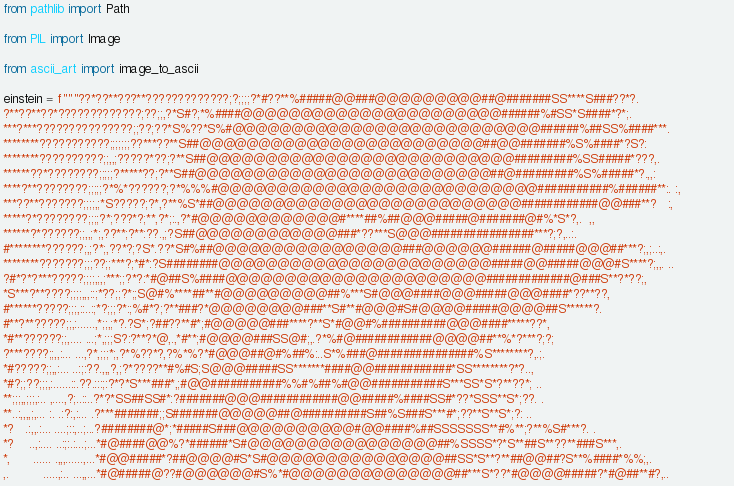Convert code to text. <code><loc_0><loc_0><loc_500><loc_500><_Python_>from pathlib import Path

from PIL import Image

from ascii_art import image_to_ascii

einstein = f"""??*??**???**?????????????;?;;;;?*#??**%#####@@###@@@@@@@@@##@#######SS****S###??*?.                 
?**??**??*?????????????;??;;,?*S#?;*%####@@@@@@@@@@@@@@@@@@@@@@######%#SS*S####*?*;.                
***?***???????????????;;??;??*S%??*S%#@@@@@@@@@@@@@@@@@@@@@@@@@@######%##SS%####***.                
********???????????;;;;;;;??***??**S##@@@@@@@@@@@@@@@@@@@@@@@@##@@#######%S%####*?S?:               
********??????????;;,,;?????*??;?**S##@@@@@@@@@@@@@@@@@@@@@@@@@@#########%SS#####*???,.             
******??*????????;;;;;?*****??;?**S##@@@@@@@@@@@@@@@@@@@@@@@@@##@#########%S%#####*?.,,:            
****?**????????;;;;;?*%*??????;?*%%%#@@@@@@@@@@@@@@@@@@@@@@@@@@@###########%######**:. :,           
***??**???????;;;;,;*S?????;?*,?**%S*##@@@@@@@@@@@@@@@@@@@@@@@@@@############@@###**?   :,          
*****?*????????;;;;?*;???*?;**,?*;:.,?*#@@@@@@@@@@@@#****##%##@@@#####@#######@#%*S*?,.  ,,         
******?*??????;;,,;*;,??**;?**:??.,;?S##@@@@@@@@@@@@###*??***S@@@################***?;?,..:.        
#********??????;,;?*;,??*?;?S*.??*S#%##@@@@@@@@@@@@@@@@###@@@@@@######@#####@@@##***?;,;..:,.       
********???????;;;??;;***?;*#*:?S########@@@@@@@@@@@@@@@@@@@@@@@#####@@#####@@@#S****?;,,. ..       
?#*?*?***?????;;;;,;,;***;;?*?:*#@##S%####@@@@@@@@@@@@@@@@@@@@@@#############@###S**?*??;,          
*S***?**????;;;;,,,::;*??;;?*;;S@#%****##**#@@@@@@@@@##%***S#@@@####@@@#####@@@####*??**??,         
#******?????;;;,::..:;*?;;;?*:;%#*?;?**###?*@@@@@@@@###**S#**#@@@#S#@@@@#####@@@@##S******?.        
#**?**?????;;,:......,*;;,;*?.?S*;?##??**#*;#@@@@@###****?**S*#@@#%##########@@@####*****??*,       
*#**??????;;,.... ...;*,;;;S?:?**?*@,.,*#**;#@@@@###SS@#;,.?*%#@############@@@@##**%*?***?;?;      
?***????;;,,:... ...,?*,;;;*;,?*%??*?,?%*%?*#@@@##@#%##%:..S*%###@###############%S********?,.;.    
*#?????;;,,:... ..:;:??.,,,?,;?*????**#%#S;S@@@#####SS*******####@@############*SS********?*?..,    
*#?;;??;;;,:......::.??.:::;:?*?*S***###*,;#@@###########%%#%##%#@@###########S***SS*S*?**??*; ..   
**;;;,,;;;,:.. ,....,?;..::..?*?*SS##SS#*:?#######@@@############@@#####%####SS#*??*SSS**S*;??. .   
**..:,,,,;,... :. .:?:,:... .?***#######;;S#######@@@@@##@##########S##%S###S***#*;??**S**S*;?: ..  
*?   .:,,.:... ....;::,..;...?########@*;*#####S###@@@@@@@@@@#@@####%##SSSSSSS**#%**;?**%S#***?. .  
*?    ..,:.... ..:;:.:...;...*#@####@@%?*######*S#@@@@@@@@@@@@@@@@##%SSSS*?*S**##S**??**###S***,.   
*,      ...... .,,,......,...*#@@#####*?##@@@@#S*S#@@@@@@@@@@@@@@@##SS*S**?**##@@##?S**%####*%%;,.  
,.         .....,:.. ...,,...*#@#####@??#@@@@@@#S%*#@@@@@@@@@@@@@@##***S*??*#@@@@#####?*#@##**#?,.. </code> 